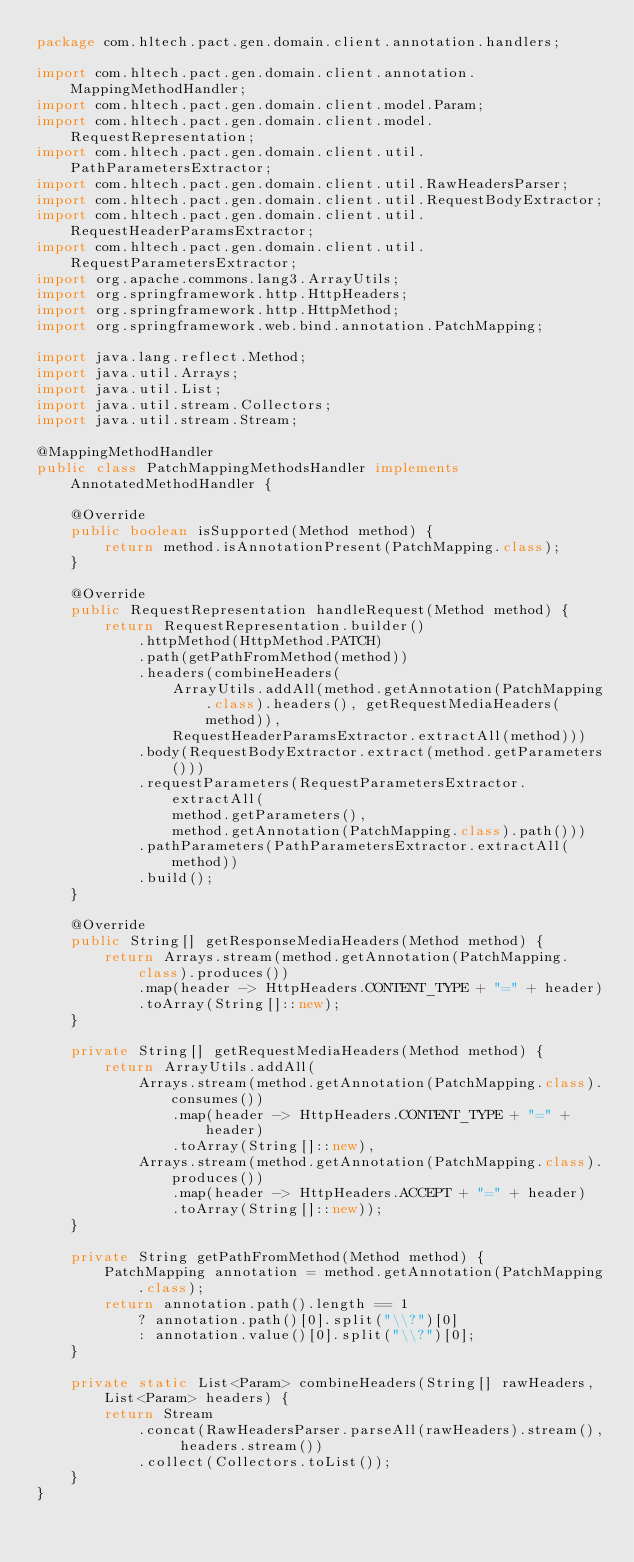<code> <loc_0><loc_0><loc_500><loc_500><_Java_>package com.hltech.pact.gen.domain.client.annotation.handlers;

import com.hltech.pact.gen.domain.client.annotation.MappingMethodHandler;
import com.hltech.pact.gen.domain.client.model.Param;
import com.hltech.pact.gen.domain.client.model.RequestRepresentation;
import com.hltech.pact.gen.domain.client.util.PathParametersExtractor;
import com.hltech.pact.gen.domain.client.util.RawHeadersParser;
import com.hltech.pact.gen.domain.client.util.RequestBodyExtractor;
import com.hltech.pact.gen.domain.client.util.RequestHeaderParamsExtractor;
import com.hltech.pact.gen.domain.client.util.RequestParametersExtractor;
import org.apache.commons.lang3.ArrayUtils;
import org.springframework.http.HttpHeaders;
import org.springframework.http.HttpMethod;
import org.springframework.web.bind.annotation.PatchMapping;

import java.lang.reflect.Method;
import java.util.Arrays;
import java.util.List;
import java.util.stream.Collectors;
import java.util.stream.Stream;

@MappingMethodHandler
public class PatchMappingMethodsHandler implements AnnotatedMethodHandler {

    @Override
    public boolean isSupported(Method method) {
        return method.isAnnotationPresent(PatchMapping.class);
    }

    @Override
    public RequestRepresentation handleRequest(Method method) {
        return RequestRepresentation.builder()
            .httpMethod(HttpMethod.PATCH)
            .path(getPathFromMethod(method))
            .headers(combineHeaders(
                ArrayUtils.addAll(method.getAnnotation(PatchMapping.class).headers(), getRequestMediaHeaders(method)),
                RequestHeaderParamsExtractor.extractAll(method)))
            .body(RequestBodyExtractor.extract(method.getParameters()))
            .requestParameters(RequestParametersExtractor.extractAll(
                method.getParameters(),
                method.getAnnotation(PatchMapping.class).path()))
            .pathParameters(PathParametersExtractor.extractAll(method))
            .build();
    }

    @Override
    public String[] getResponseMediaHeaders(Method method) {
        return Arrays.stream(method.getAnnotation(PatchMapping.class).produces())
            .map(header -> HttpHeaders.CONTENT_TYPE + "=" + header)
            .toArray(String[]::new);
    }

    private String[] getRequestMediaHeaders(Method method) {
        return ArrayUtils.addAll(
            Arrays.stream(method.getAnnotation(PatchMapping.class).consumes())
                .map(header -> HttpHeaders.CONTENT_TYPE + "=" + header)
                .toArray(String[]::new),
            Arrays.stream(method.getAnnotation(PatchMapping.class).produces())
                .map(header -> HttpHeaders.ACCEPT + "=" + header)
                .toArray(String[]::new));
    }

    private String getPathFromMethod(Method method) {
        PatchMapping annotation = method.getAnnotation(PatchMapping.class);
        return annotation.path().length == 1
            ? annotation.path()[0].split("\\?")[0]
            : annotation.value()[0].split("\\?")[0];
    }

    private static List<Param> combineHeaders(String[] rawHeaders, List<Param> headers) {
        return Stream
            .concat(RawHeadersParser.parseAll(rawHeaders).stream(), headers.stream())
            .collect(Collectors.toList());
    }
}
</code> 